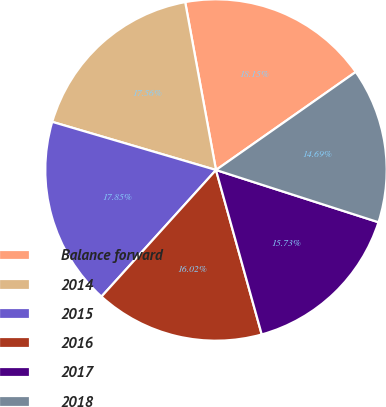Convert chart. <chart><loc_0><loc_0><loc_500><loc_500><pie_chart><fcel>Balance forward<fcel>2014<fcel>2015<fcel>2016<fcel>2017<fcel>2018<nl><fcel>18.15%<fcel>17.56%<fcel>17.85%<fcel>16.02%<fcel>15.73%<fcel>14.69%<nl></chart> 